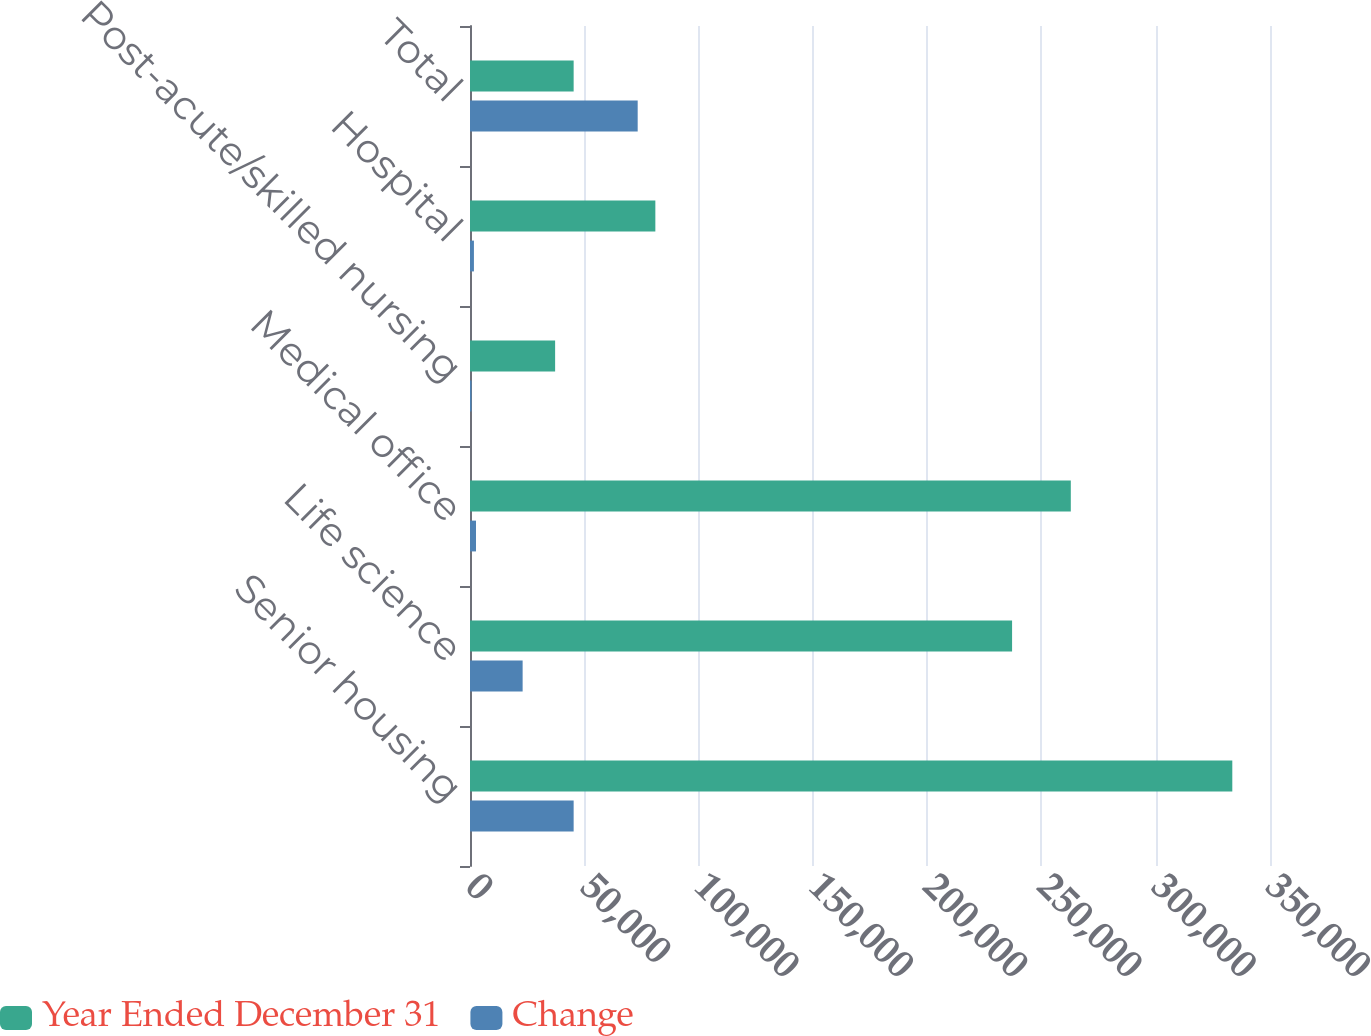Convert chart to OTSL. <chart><loc_0><loc_0><loc_500><loc_500><stacked_bar_chart><ecel><fcel>Senior housing<fcel>Life science<fcel>Medical office<fcel>Post-acute/skilled nursing<fcel>Hospital<fcel>Total<nl><fcel>Year Ended December 31<fcel>333508<fcel>237160<fcel>262854<fcel>37242<fcel>81091<fcel>45345<nl><fcel>Change<fcel>45345<fcel>23026<fcel>2616<fcel>657<fcel>1719<fcel>73363<nl></chart> 